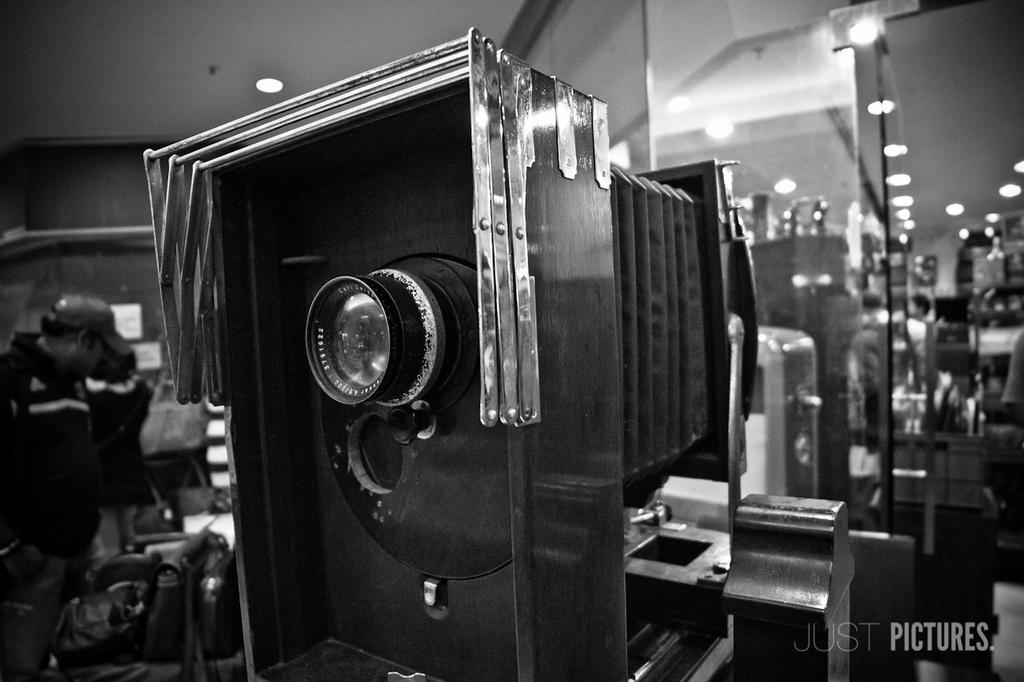How would you summarize this image in a sentence or two? This image consists of a camera in black color. On the left, we can see a person standing. On the right, there is a mirror. At the top, there is a roof along with the light. 